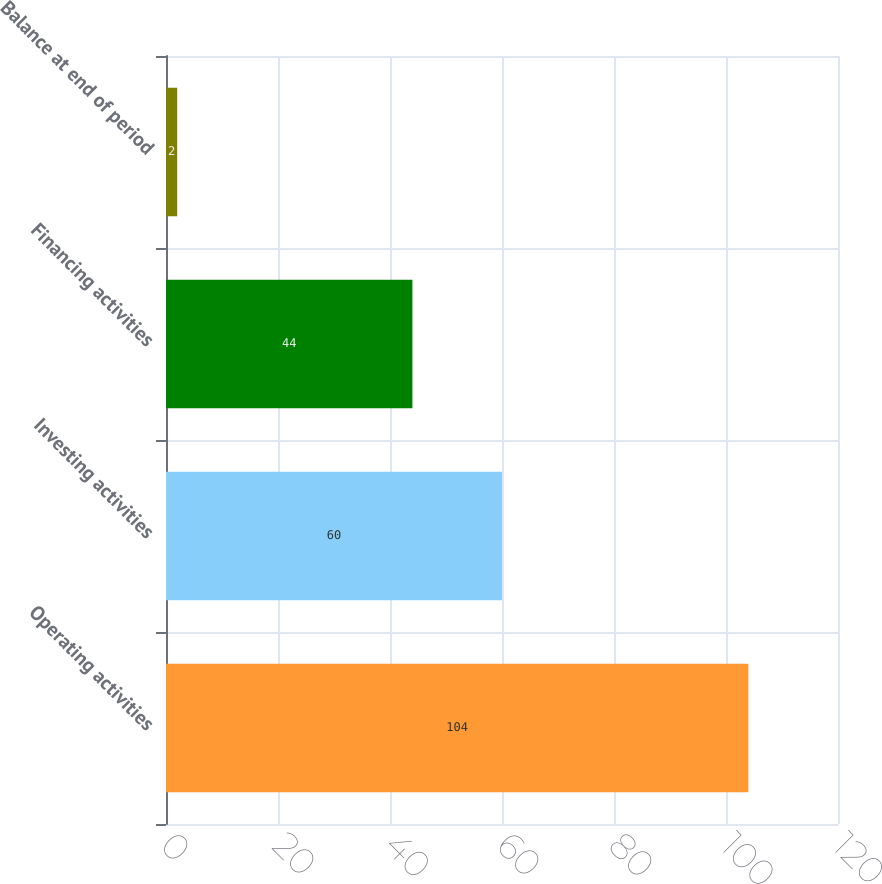Convert chart to OTSL. <chart><loc_0><loc_0><loc_500><loc_500><bar_chart><fcel>Operating activities<fcel>Investing activities<fcel>Financing activities<fcel>Balance at end of period<nl><fcel>104<fcel>60<fcel>44<fcel>2<nl></chart> 